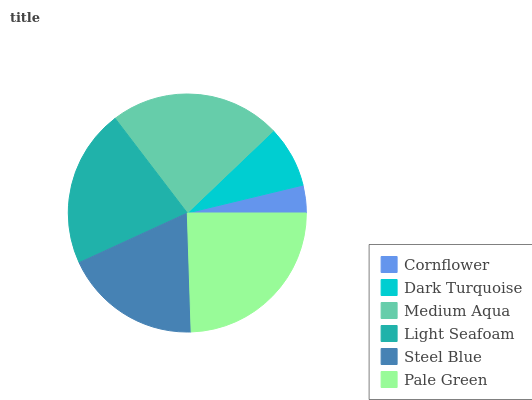Is Cornflower the minimum?
Answer yes or no. Yes. Is Pale Green the maximum?
Answer yes or no. Yes. Is Dark Turquoise the minimum?
Answer yes or no. No. Is Dark Turquoise the maximum?
Answer yes or no. No. Is Dark Turquoise greater than Cornflower?
Answer yes or no. Yes. Is Cornflower less than Dark Turquoise?
Answer yes or no. Yes. Is Cornflower greater than Dark Turquoise?
Answer yes or no. No. Is Dark Turquoise less than Cornflower?
Answer yes or no. No. Is Light Seafoam the high median?
Answer yes or no. Yes. Is Steel Blue the low median?
Answer yes or no. Yes. Is Dark Turquoise the high median?
Answer yes or no. No. Is Dark Turquoise the low median?
Answer yes or no. No. 